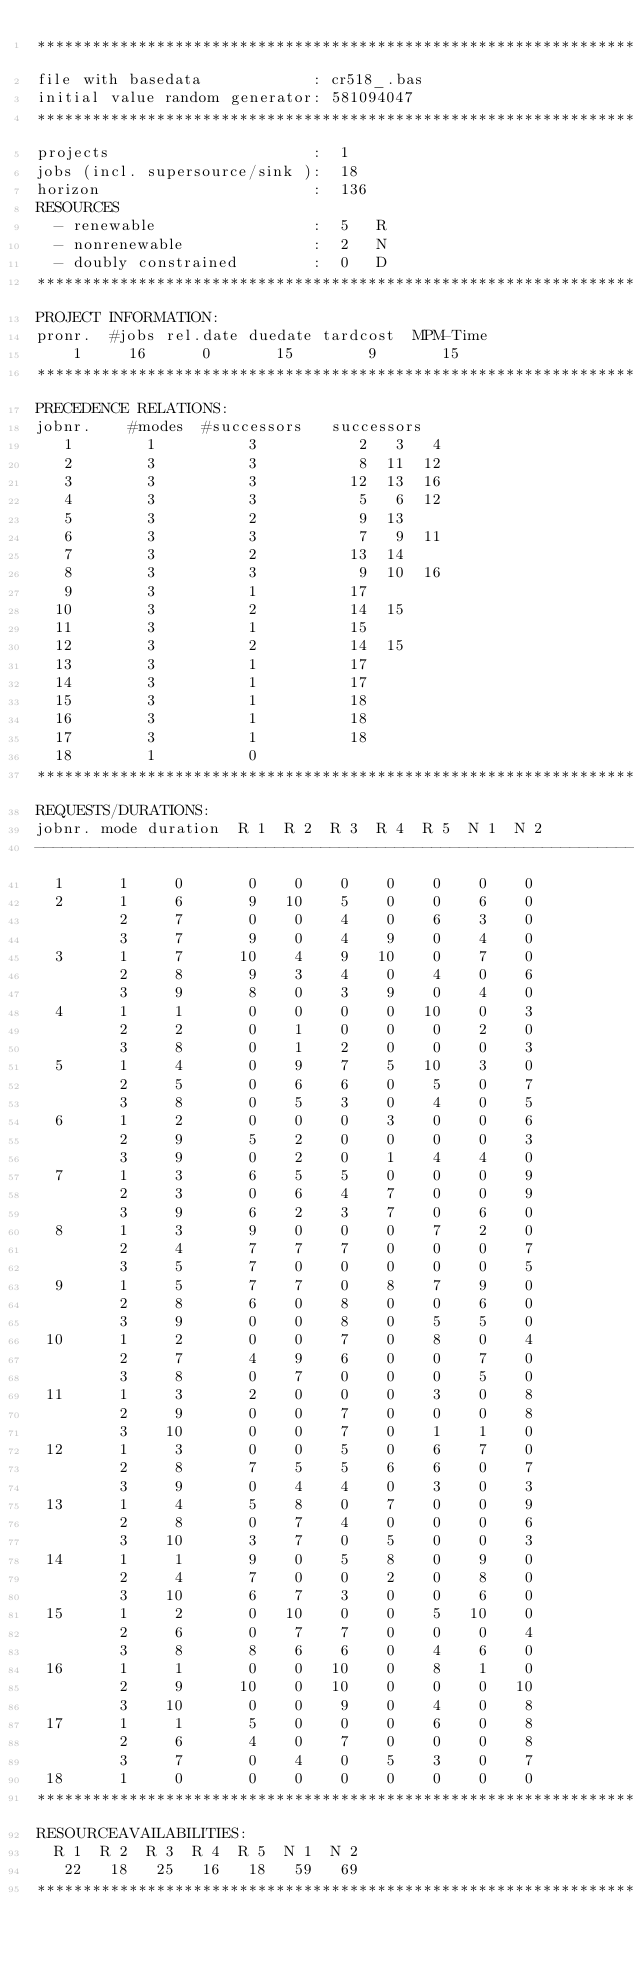Convert code to text. <code><loc_0><loc_0><loc_500><loc_500><_ObjectiveC_>************************************************************************
file with basedata            : cr518_.bas
initial value random generator: 581094047
************************************************************************
projects                      :  1
jobs (incl. supersource/sink ):  18
horizon                       :  136
RESOURCES
  - renewable                 :  5   R
  - nonrenewable              :  2   N
  - doubly constrained        :  0   D
************************************************************************
PROJECT INFORMATION:
pronr.  #jobs rel.date duedate tardcost  MPM-Time
    1     16      0       15        9       15
************************************************************************
PRECEDENCE RELATIONS:
jobnr.    #modes  #successors   successors
   1        1          3           2   3   4
   2        3          3           8  11  12
   3        3          3          12  13  16
   4        3          3           5   6  12
   5        3          2           9  13
   6        3          3           7   9  11
   7        3          2          13  14
   8        3          3           9  10  16
   9        3          1          17
  10        3          2          14  15
  11        3          1          15
  12        3          2          14  15
  13        3          1          17
  14        3          1          17
  15        3          1          18
  16        3          1          18
  17        3          1          18
  18        1          0        
************************************************************************
REQUESTS/DURATIONS:
jobnr. mode duration  R 1  R 2  R 3  R 4  R 5  N 1  N 2
------------------------------------------------------------------------
  1      1     0       0    0    0    0    0    0    0
  2      1     6       9   10    5    0    0    6    0
         2     7       0    0    4    0    6    3    0
         3     7       9    0    4    9    0    4    0
  3      1     7      10    4    9   10    0    7    0
         2     8       9    3    4    0    4    0    6
         3     9       8    0    3    9    0    4    0
  4      1     1       0    0    0    0   10    0    3
         2     2       0    1    0    0    0    2    0
         3     8       0    1    2    0    0    0    3
  5      1     4       0    9    7    5   10    3    0
         2     5       0    6    6    0    5    0    7
         3     8       0    5    3    0    4    0    5
  6      1     2       0    0    0    3    0    0    6
         2     9       5    2    0    0    0    0    3
         3     9       0    2    0    1    4    4    0
  7      1     3       6    5    5    0    0    0    9
         2     3       0    6    4    7    0    0    9
         3     9       6    2    3    7    0    6    0
  8      1     3       9    0    0    0    7    2    0
         2     4       7    7    7    0    0    0    7
         3     5       7    0    0    0    0    0    5
  9      1     5       7    7    0    8    7    9    0
         2     8       6    0    8    0    0    6    0
         3     9       0    0    8    0    5    5    0
 10      1     2       0    0    7    0    8    0    4
         2     7       4    9    6    0    0    7    0
         3     8       0    7    0    0    0    5    0
 11      1     3       2    0    0    0    3    0    8
         2     9       0    0    7    0    0    0    8
         3    10       0    0    7    0    1    1    0
 12      1     3       0    0    5    0    6    7    0
         2     8       7    5    5    6    6    0    7
         3     9       0    4    4    0    3    0    3
 13      1     4       5    8    0    7    0    0    9
         2     8       0    7    4    0    0    0    6
         3    10       3    7    0    5    0    0    3
 14      1     1       9    0    5    8    0    9    0
         2     4       7    0    0    2    0    8    0
         3    10       6    7    3    0    0    6    0
 15      1     2       0   10    0    0    5   10    0
         2     6       0    7    7    0    0    0    4
         3     8       8    6    6    0    4    6    0
 16      1     1       0    0   10    0    8    1    0
         2     9      10    0   10    0    0    0   10
         3    10       0    0    9    0    4    0    8
 17      1     1       5    0    0    0    6    0    8
         2     6       4    0    7    0    0    0    8
         3     7       0    4    0    5    3    0    7
 18      1     0       0    0    0    0    0    0    0
************************************************************************
RESOURCEAVAILABILITIES:
  R 1  R 2  R 3  R 4  R 5  N 1  N 2
   22   18   25   16   18   59   69
************************************************************************
</code> 